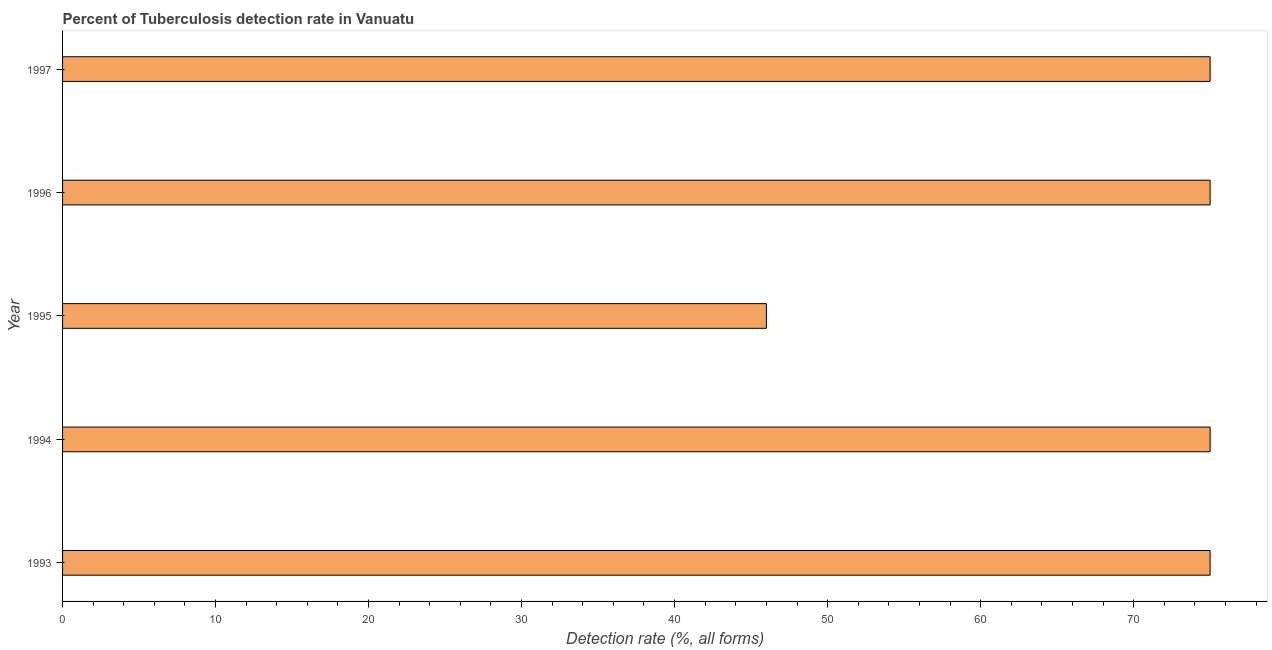What is the title of the graph?
Keep it short and to the point. Percent of Tuberculosis detection rate in Vanuatu. What is the label or title of the X-axis?
Give a very brief answer. Detection rate (%, all forms). What is the label or title of the Y-axis?
Your answer should be very brief. Year. Across all years, what is the maximum detection rate of tuberculosis?
Your response must be concise. 75. Across all years, what is the minimum detection rate of tuberculosis?
Give a very brief answer. 46. What is the sum of the detection rate of tuberculosis?
Offer a very short reply. 346. What is the median detection rate of tuberculosis?
Make the answer very short. 75. What is the ratio of the detection rate of tuberculosis in 1993 to that in 1995?
Keep it short and to the point. 1.63. Is the difference between the detection rate of tuberculosis in 1994 and 1997 greater than the difference between any two years?
Give a very brief answer. No. Is the sum of the detection rate of tuberculosis in 1995 and 1997 greater than the maximum detection rate of tuberculosis across all years?
Ensure brevity in your answer.  Yes. What is the difference between the highest and the lowest detection rate of tuberculosis?
Offer a very short reply. 29. How many years are there in the graph?
Provide a short and direct response. 5. What is the difference between two consecutive major ticks on the X-axis?
Provide a succinct answer. 10. What is the Detection rate (%, all forms) in 1993?
Offer a very short reply. 75. What is the Detection rate (%, all forms) of 1994?
Your response must be concise. 75. What is the Detection rate (%, all forms) in 1996?
Your response must be concise. 75. What is the Detection rate (%, all forms) in 1997?
Provide a succinct answer. 75. What is the difference between the Detection rate (%, all forms) in 1993 and 1997?
Your answer should be very brief. 0. What is the difference between the Detection rate (%, all forms) in 1994 and 1997?
Provide a succinct answer. 0. What is the difference between the Detection rate (%, all forms) in 1995 and 1996?
Your answer should be compact. -29. What is the difference between the Detection rate (%, all forms) in 1996 and 1997?
Your response must be concise. 0. What is the ratio of the Detection rate (%, all forms) in 1993 to that in 1994?
Provide a short and direct response. 1. What is the ratio of the Detection rate (%, all forms) in 1993 to that in 1995?
Provide a short and direct response. 1.63. What is the ratio of the Detection rate (%, all forms) in 1993 to that in 1996?
Provide a succinct answer. 1. What is the ratio of the Detection rate (%, all forms) in 1994 to that in 1995?
Your answer should be compact. 1.63. What is the ratio of the Detection rate (%, all forms) in 1995 to that in 1996?
Make the answer very short. 0.61. What is the ratio of the Detection rate (%, all forms) in 1995 to that in 1997?
Provide a short and direct response. 0.61. What is the ratio of the Detection rate (%, all forms) in 1996 to that in 1997?
Your response must be concise. 1. 